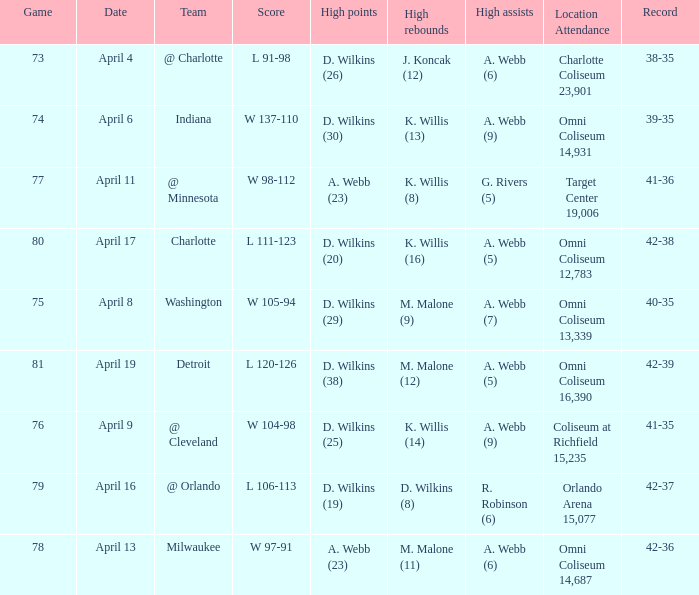Parse the full table. {'header': ['Game', 'Date', 'Team', 'Score', 'High points', 'High rebounds', 'High assists', 'Location Attendance', 'Record'], 'rows': [['73', 'April 4', '@ Charlotte', 'L 91-98', 'D. Wilkins (26)', 'J. Koncak (12)', 'A. Webb (6)', 'Charlotte Coliseum 23,901', '38-35'], ['74', 'April 6', 'Indiana', 'W 137-110', 'D. Wilkins (30)', 'K. Willis (13)', 'A. Webb (9)', 'Omni Coliseum 14,931', '39-35'], ['77', 'April 11', '@ Minnesota', 'W 98-112', 'A. Webb (23)', 'K. Willis (8)', 'G. Rivers (5)', 'Target Center 19,006', '41-36'], ['80', 'April 17', 'Charlotte', 'L 111-123', 'D. Wilkins (20)', 'K. Willis (16)', 'A. Webb (5)', 'Omni Coliseum 12,783', '42-38'], ['75', 'April 8', 'Washington', 'W 105-94', 'D. Wilkins (29)', 'M. Malone (9)', 'A. Webb (7)', 'Omni Coliseum 13,339', '40-35'], ['81', 'April 19', 'Detroit', 'L 120-126', 'D. Wilkins (38)', 'M. Malone (12)', 'A. Webb (5)', 'Omni Coliseum 16,390', '42-39'], ['76', 'April 9', '@ Cleveland', 'W 104-98', 'D. Wilkins (25)', 'K. Willis (14)', 'A. Webb (9)', 'Coliseum at Richfield 15,235', '41-35'], ['79', 'April 16', '@ Orlando', 'L 106-113', 'D. Wilkins (19)', 'D. Wilkins (8)', 'R. Robinson (6)', 'Orlando Arena 15,077', '42-37'], ['78', 'April 13', 'Milwaukee', 'W 97-91', 'A. Webb (23)', 'M. Malone (11)', 'A. Webb (6)', 'Omni Coliseum 14,687', '42-36']]} What date was the game score w 104-98? April 9. 